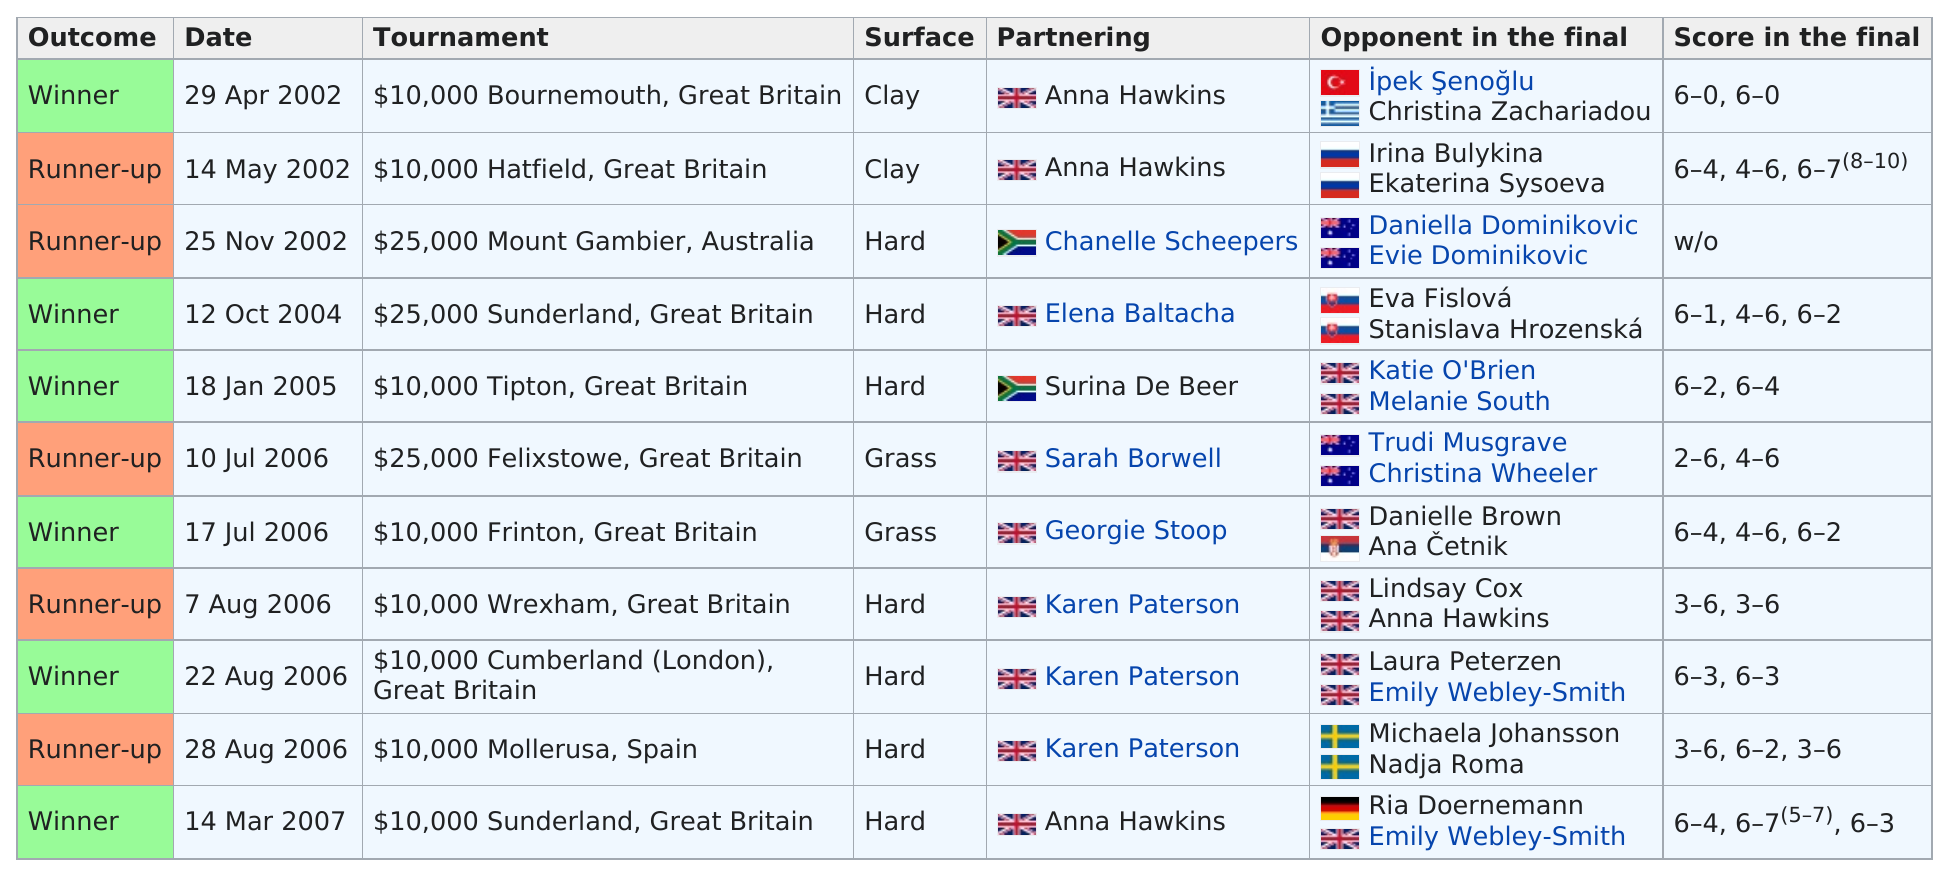Highlight a few significant elements in this photo. On May 14th, 2002, the prize money for the tournament was $10,000. Jane O'Donoghue won the competition before 2005 at least 2 times. The name of the individual above Chanelle Scheepers is Anna Hawkins. There are two surfaces that are grass. She won in October 2004, and her next win occurred on January 18, 2005. 